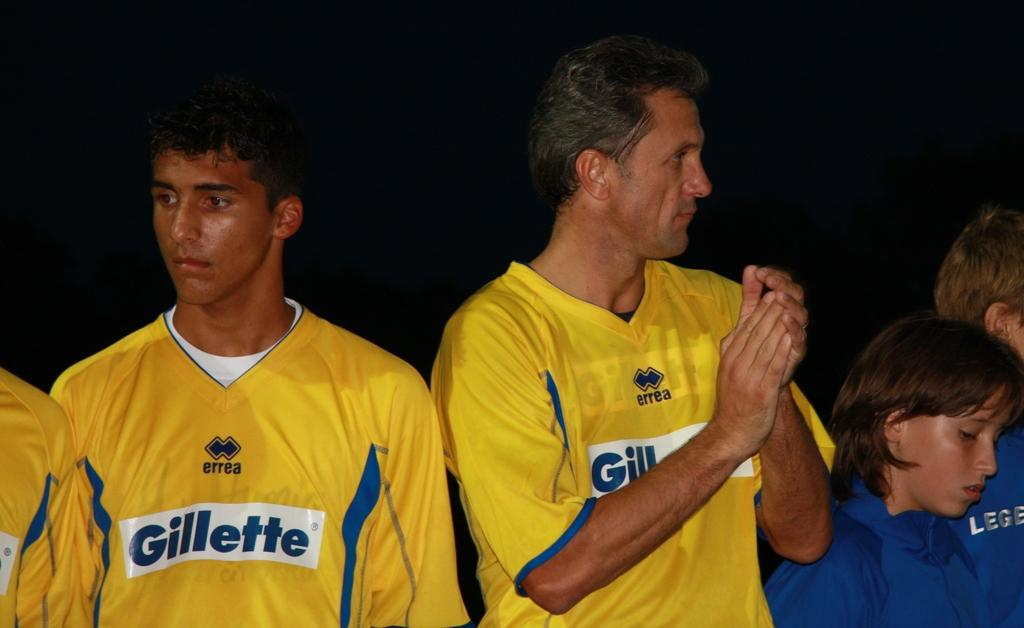Provide a one-sentence caption for the provided image. people in yellow Gillette sports jerseys outside at night. 